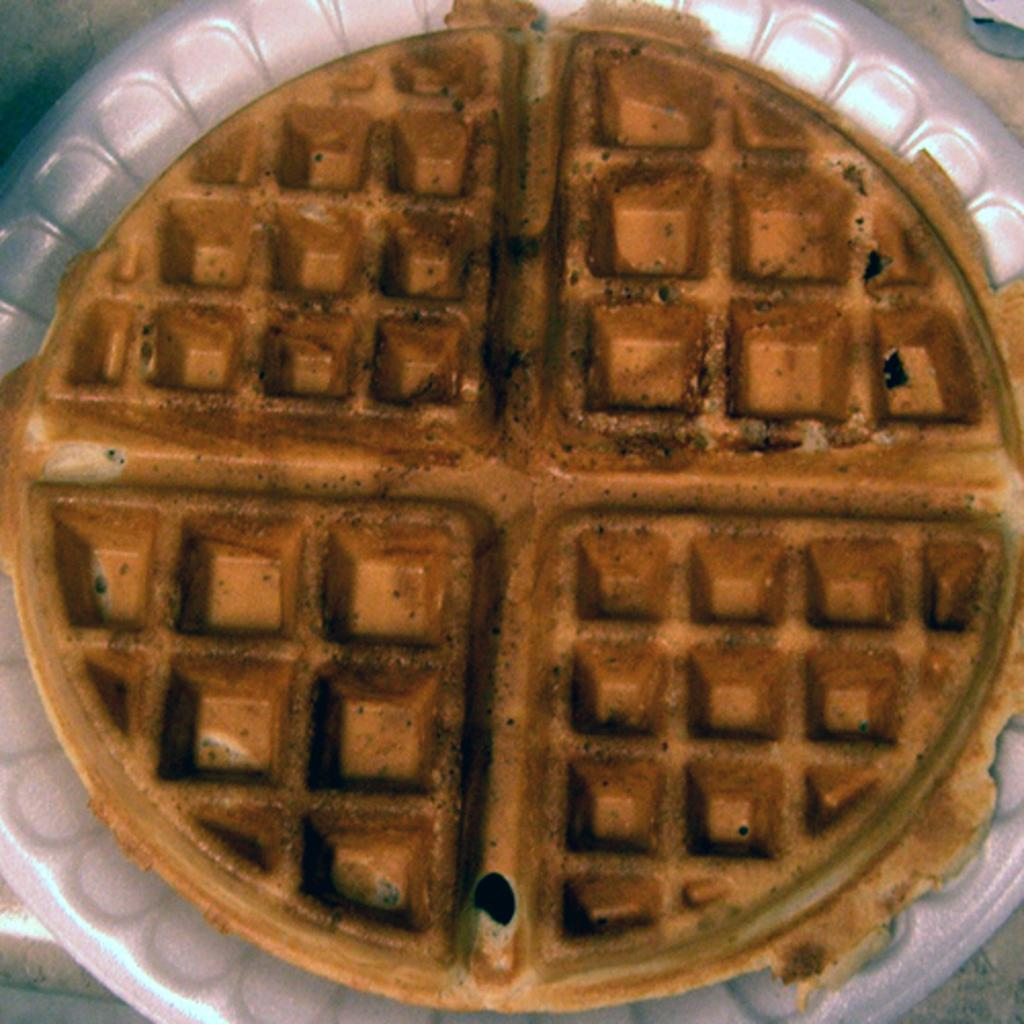What is present on the plate in the image? There is a waffle on the plate in the image. Can you describe the main food item in the image? The main food item in the image is a waffle. What type of noise can be heard coming from the edge of the waffle in the image? There is no noise present in the image, and the edge of the waffle cannot produce sound. 